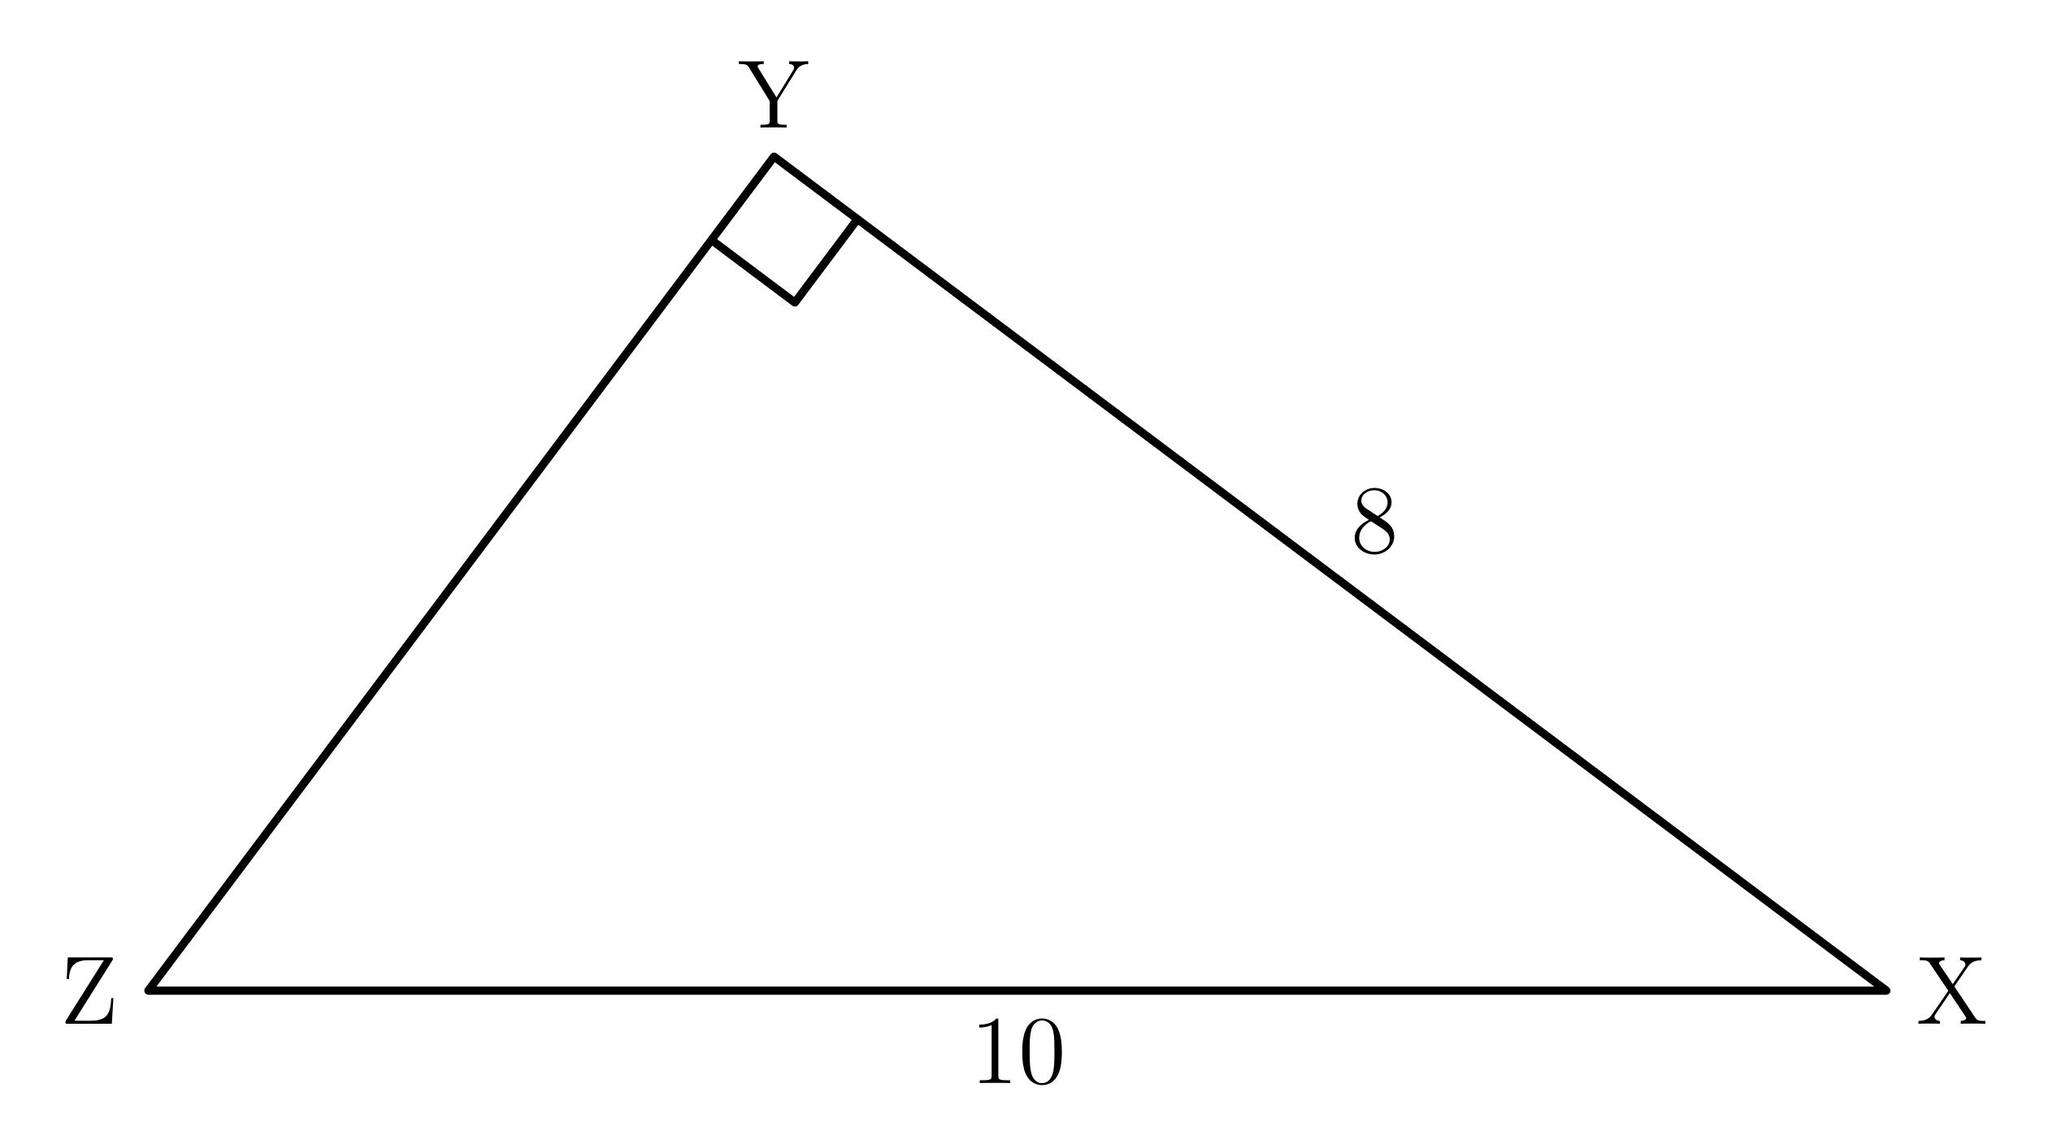In right triangle $XYZ$, shown below, what is $\sin{X}$? To find the sine of angle X, you need to identify the length of the side opposite the angle and the hypotenuse. In the right triangle XYZ shown, the side opposite angle X is of length 8, and the hypotenuse (side YZ) is of length 10. The sine of angle X is the ratio of the length of the side opposite to the hypotenuse, which is 8/10, thus $\sin{X} = \frac{8}{10} = \frac{4}{5}$. 